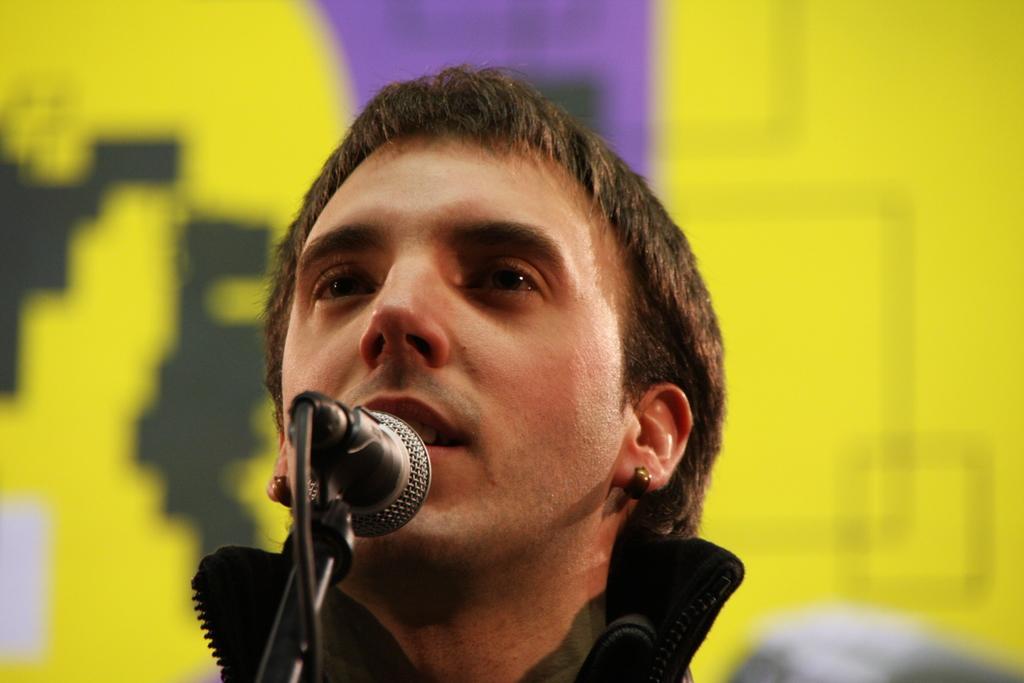Describe this image in one or two sentences. In the image we can see a man wearing clothes and earrings. Here we can see microphone, cable wire and the background is blurred. 